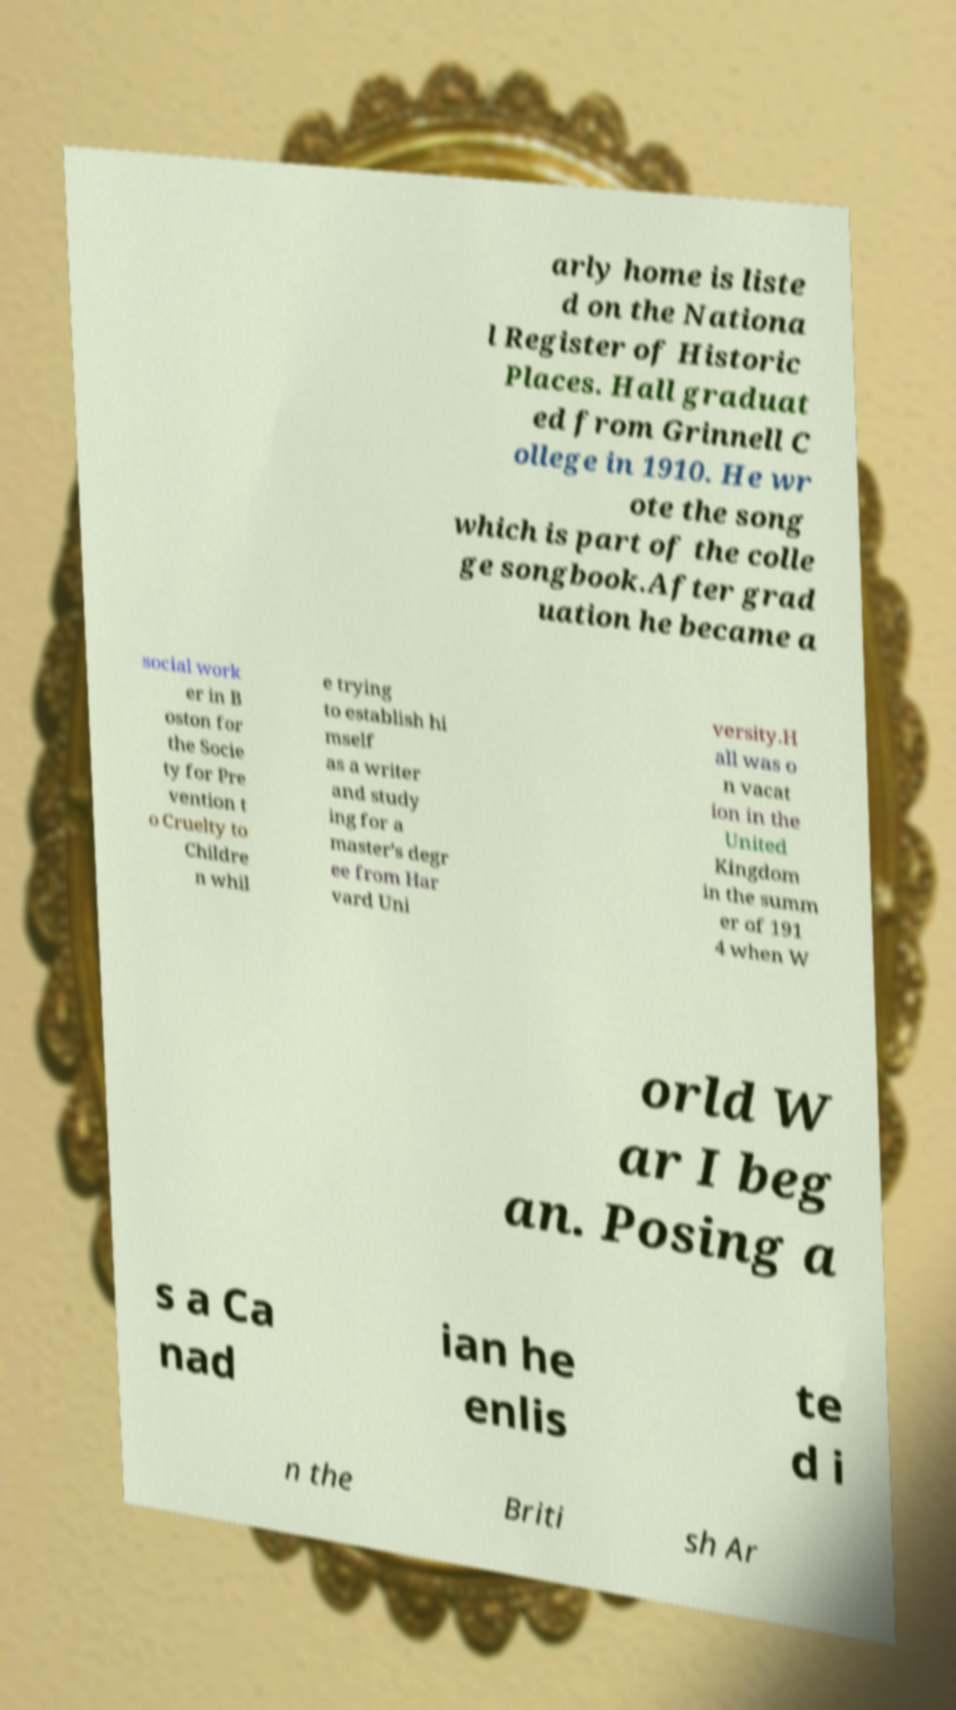There's text embedded in this image that I need extracted. Can you transcribe it verbatim? arly home is liste d on the Nationa l Register of Historic Places. Hall graduat ed from Grinnell C ollege in 1910. He wr ote the song which is part of the colle ge songbook.After grad uation he became a social work er in B oston for the Socie ty for Pre vention t o Cruelty to Childre n whil e trying to establish hi mself as a writer and study ing for a master's degr ee from Har vard Uni versity.H all was o n vacat ion in the United Kingdom in the summ er of 191 4 when W orld W ar I beg an. Posing a s a Ca nad ian he enlis te d i n the Briti sh Ar 